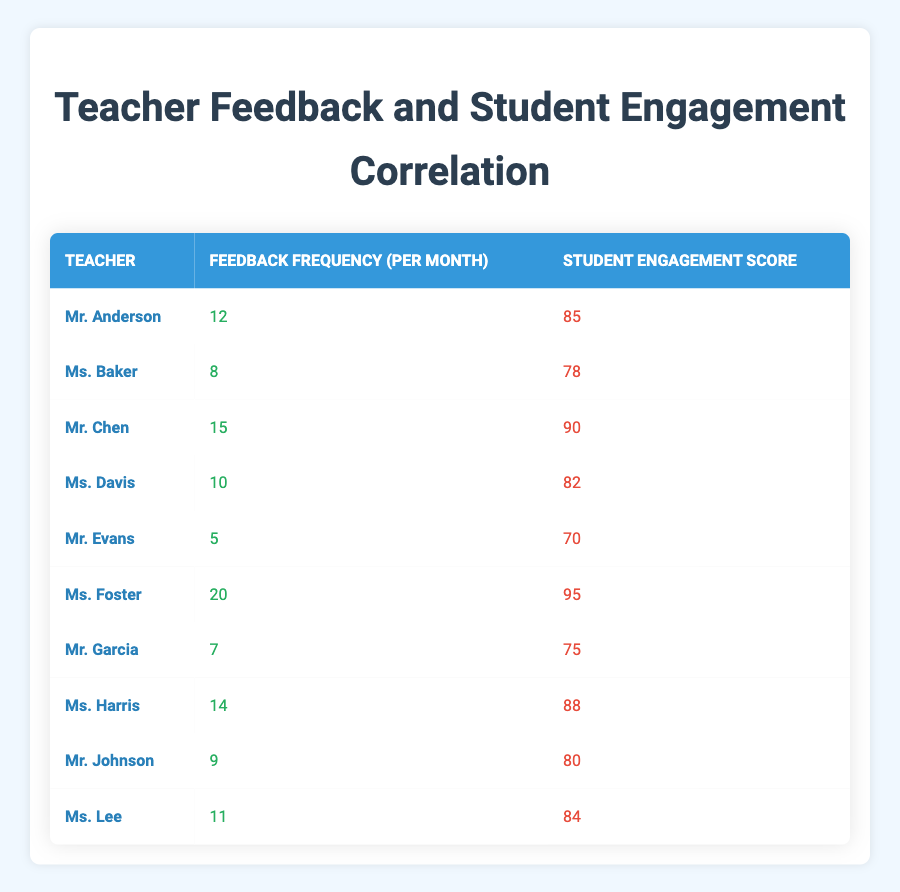What is the feedback frequency of Ms. Foster? Ms. Foster's feedback frequency can be directly found in the table, which states it as 20.
Answer: 20 What is the student engagement score of Mr. Garcia? The student engagement score for Mr. Garcia is listed in the table, showing it as 75.
Answer: 75 Which teacher has the highest feedback frequency? By reviewing the feedback frequency values in the table, Ms. Foster has the highest frequency at 20.
Answer: Ms. Foster What is the average student engagement score of the teachers listed? To find the average, sum up all student engagement scores (85 + 78 + 90 + 82 + 70 + 95 + 75 + 88 + 80 + 84 =  828) and divide by the total number of teachers (10). Thus, 828 / 10 = 82.8.
Answer: 82.8 Is it true that Mr. Johnson has a higher engagement score than Mr. Evans? By comparing the scores, Mr. Johnson has an engagement score of 80, while Mr. Evans has a score of 70. Since 80 is greater than 70, this statement is true.
Answer: Yes How does the engagement score of Mr. Chen compare to the average engagement score? The average engagement score is 82.8, and Mr. Chen's score is 90. Since 90 is greater than 82.8, Mr. Chen's score is above average.
Answer: Above average How many teachers have a feedback frequency greater than 10? Examining the feedback frequencies, Mr. Chen (15), Ms. Foster (20), and Ms. Harris (14) have frequencies greater than 10, leading to a total of three teachers.
Answer: 3 What is the difference between the engagement score of Ms. Baker and Ms. Lee? Ms. Baker's score is 78, and Ms. Lee's score is 84. The difference is calculated as 84 - 78 = 6.
Answer: 6 Is Ms. Harris's feedback frequency higher than that of Mr. Anderson? Ms. Harris has a feedback frequency of 14, while Mr. Anderson has 12. Since 14 is greater than 12, the statement is true.
Answer: Yes 